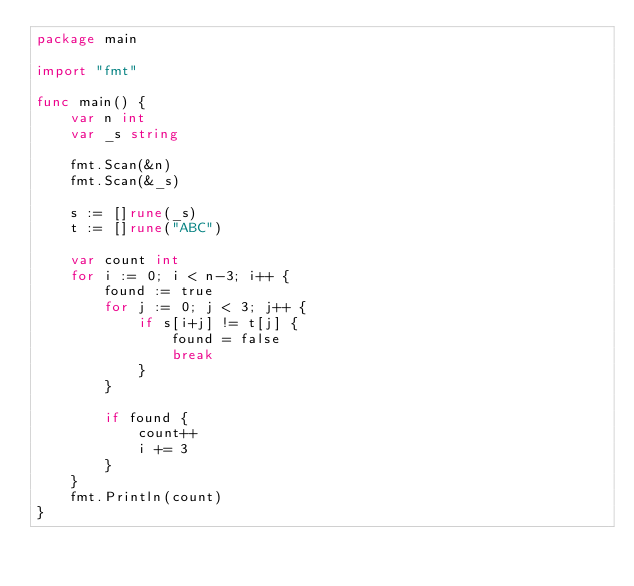Convert code to text. <code><loc_0><loc_0><loc_500><loc_500><_Go_>package main

import "fmt"

func main() {
	var n int
	var _s string

	fmt.Scan(&n)
	fmt.Scan(&_s)

	s := []rune(_s)
	t := []rune("ABC")

	var count int
	for i := 0; i < n-3; i++ {
		found := true
		for j := 0; j < 3; j++ {
			if s[i+j] != t[j] {
				found = false
				break
			}
		}

		if found {
			count++
			i += 3
		}
	}
	fmt.Println(count)
}</code> 